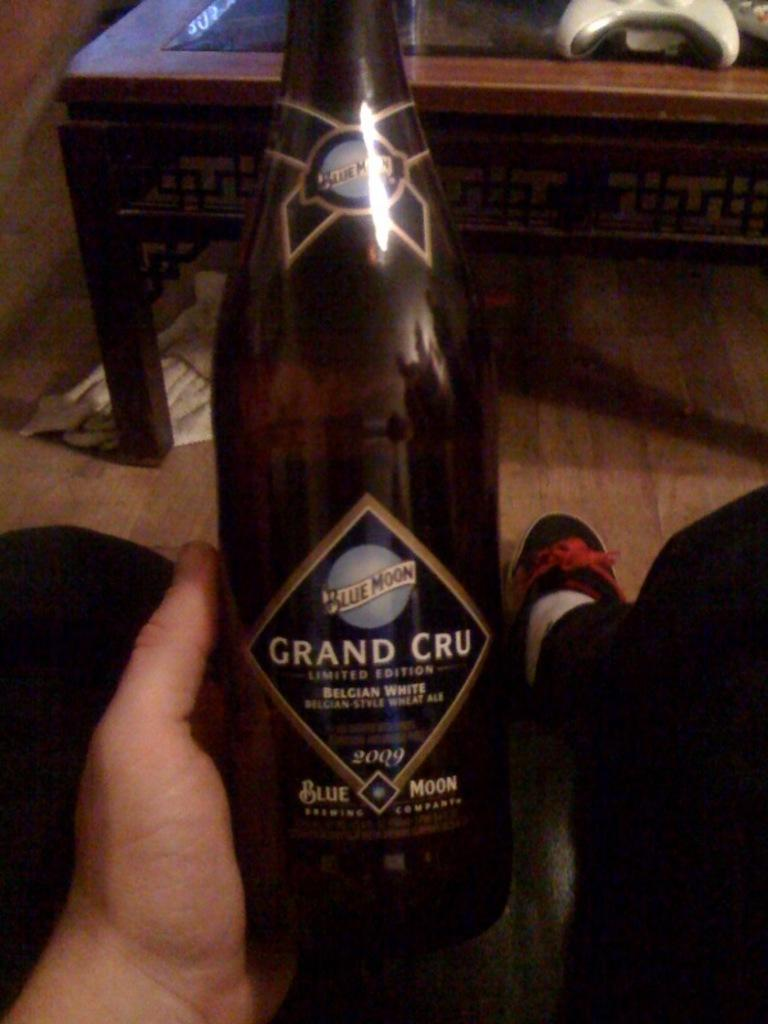<image>
Offer a succinct explanation of the picture presented. a bottle of grand cru limited edition wheat ale distributed by blue moon 